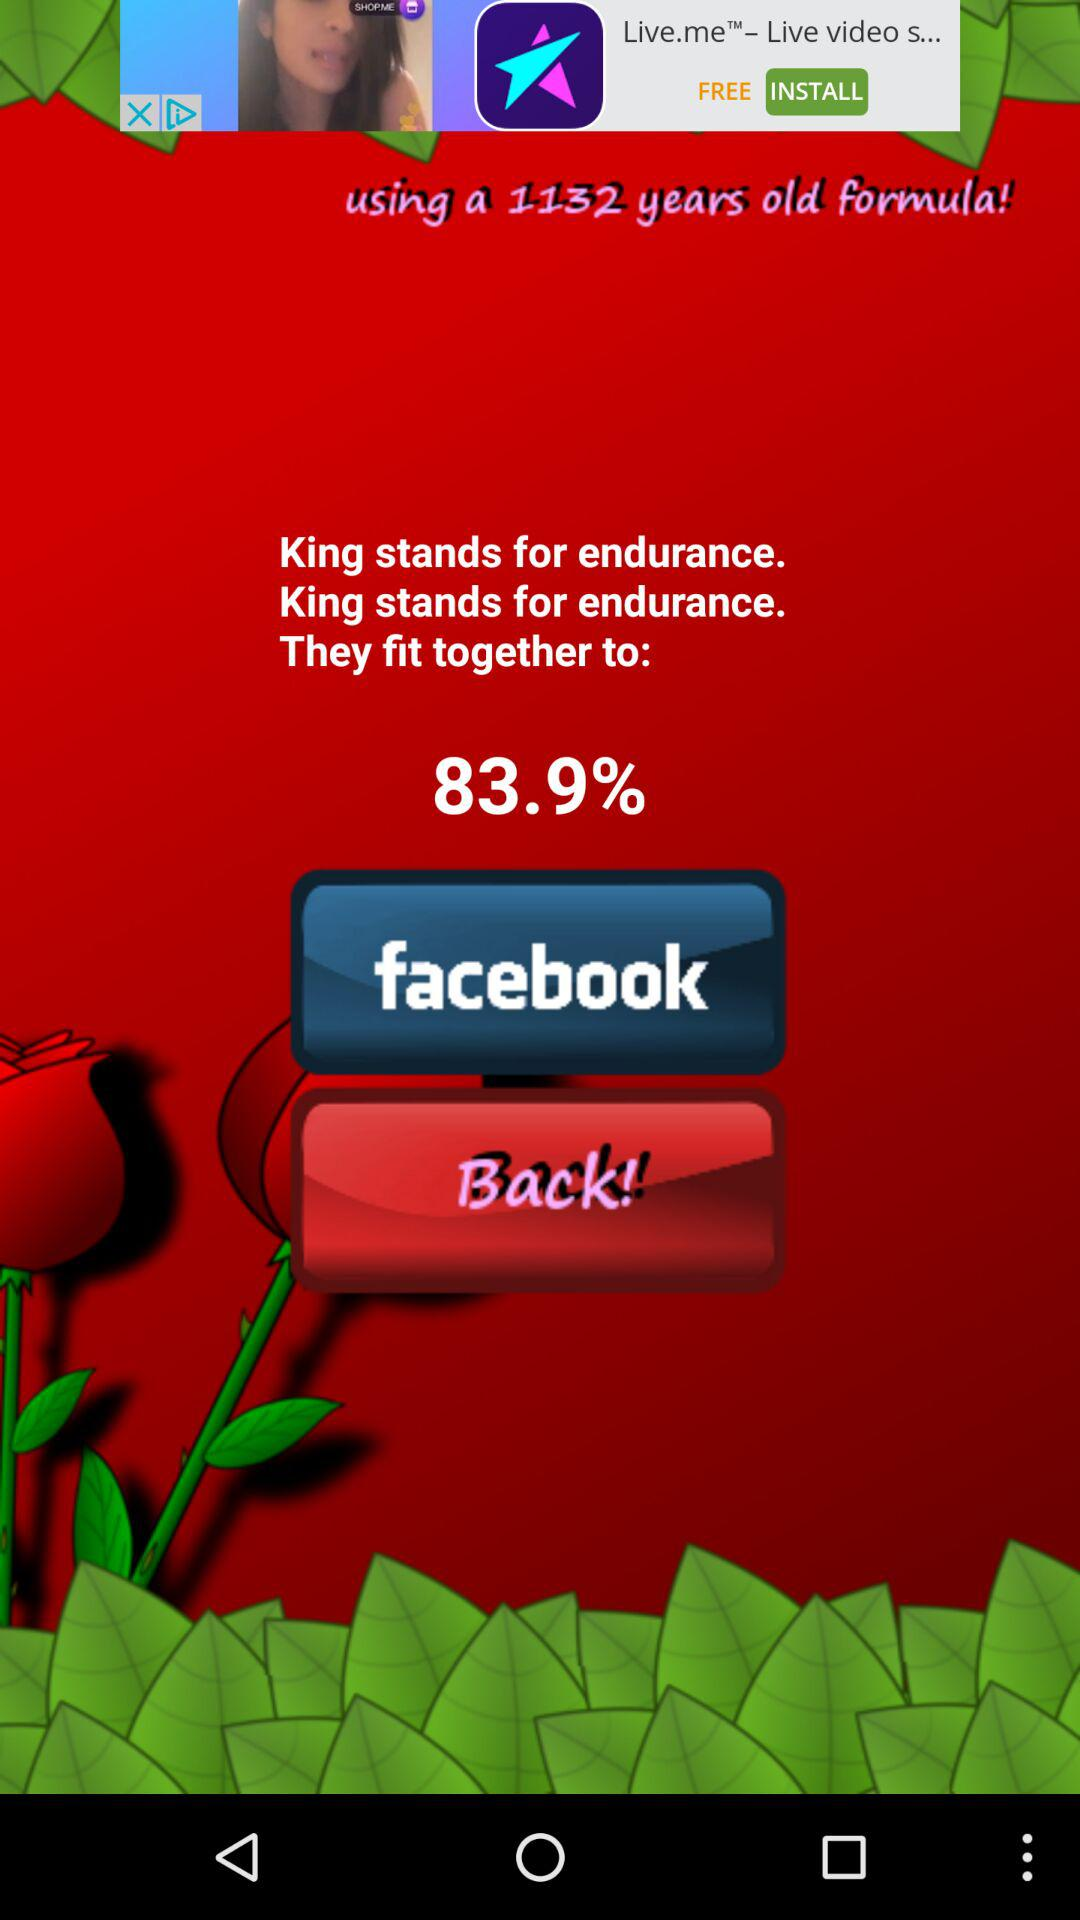For how long has the formula been in use? The formula has been in use for 1132 years. 